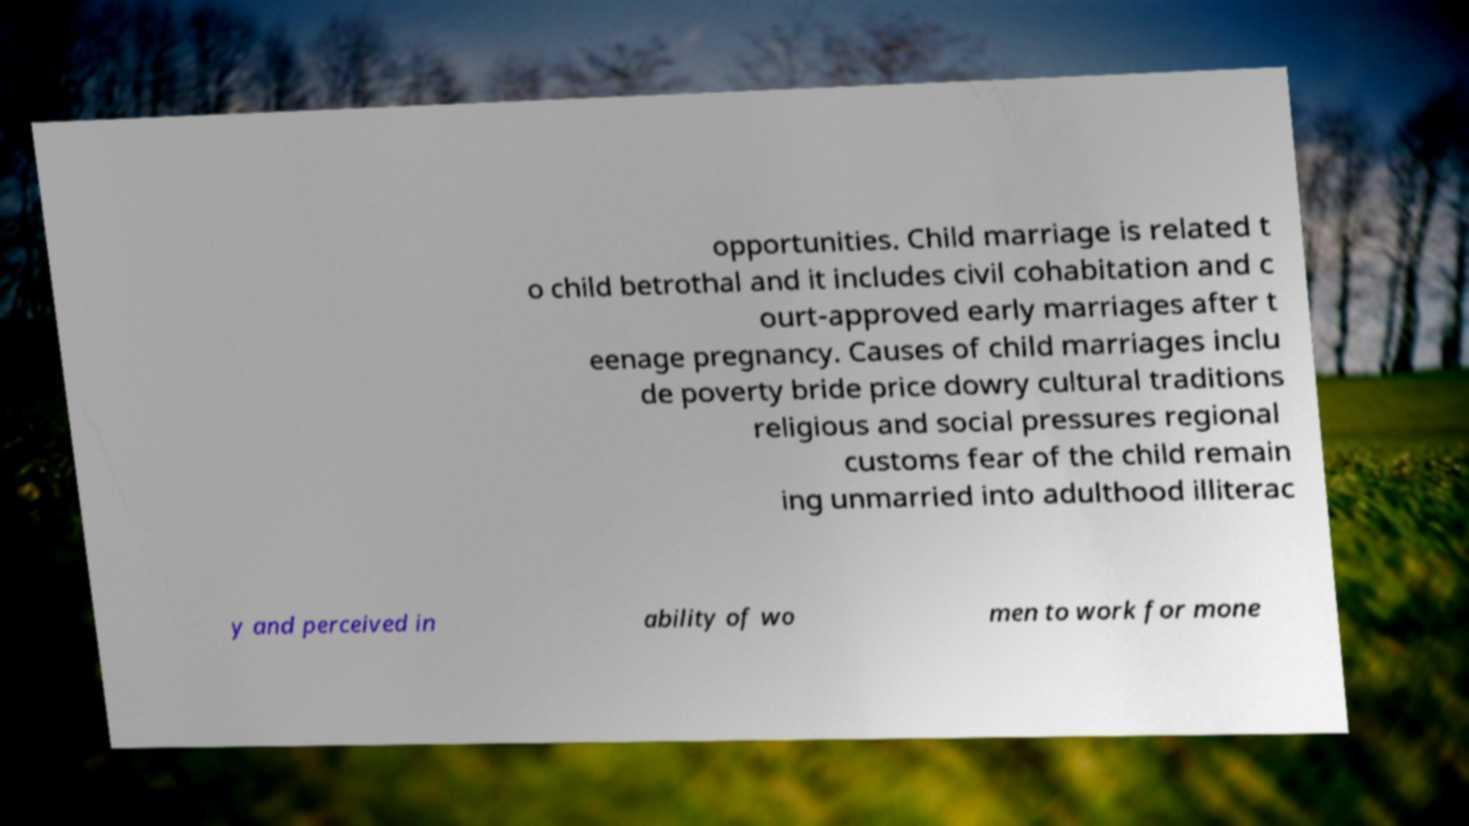Can you accurately transcribe the text from the provided image for me? opportunities. Child marriage is related t o child betrothal and it includes civil cohabitation and c ourt-approved early marriages after t eenage pregnancy. Causes of child marriages inclu de poverty bride price dowry cultural traditions religious and social pressures regional customs fear of the child remain ing unmarried into adulthood illiterac y and perceived in ability of wo men to work for mone 